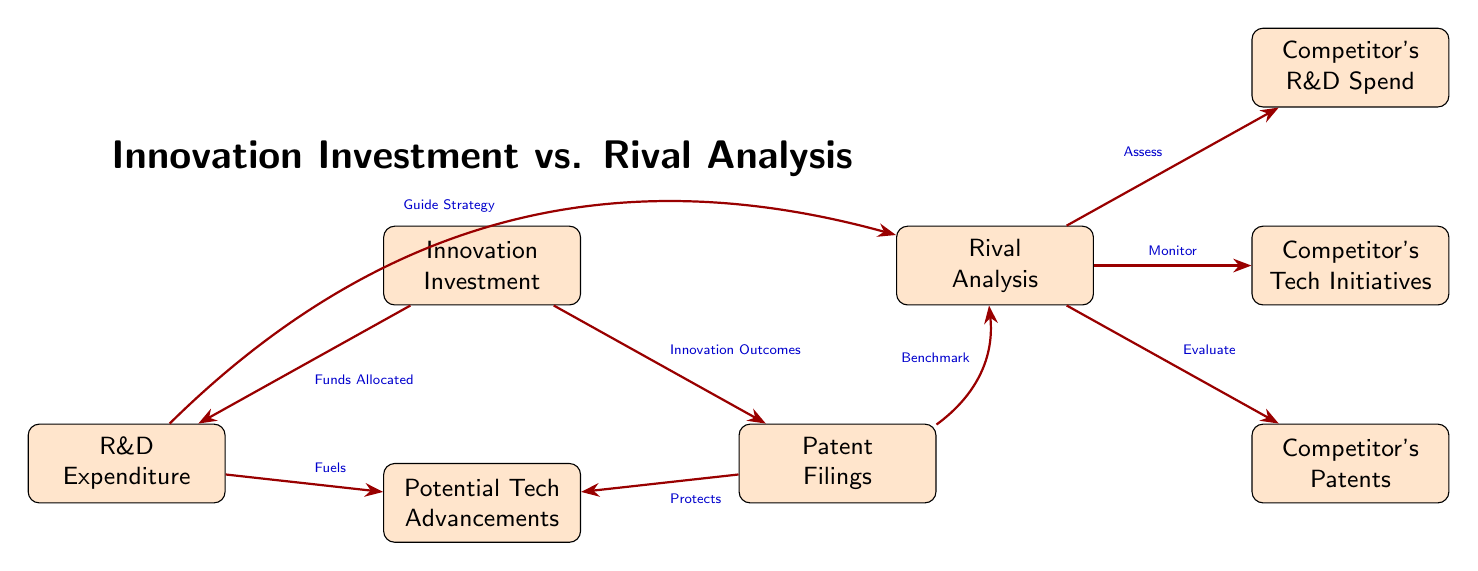What is the main focus of the diagram? The diagram illustrates the relationship between Innovation Investment and Rival Analysis, showing how R&D expenditure and patent filings contribute to potential tech advancements and how these interact with competitors.
Answer: Innovation Investment vs. Rival Analysis How many nodes are in the diagram? There are six nodes in the diagram: Innovation Investment, R&D Expenditure, Patent Filings, Potential Tech Advancements, Rival Analysis, and Competitor's Tech Initiatives.
Answer: Six nodes What are the two outcomes of Innovation Investment? The two outcomes directly linked to Innovation Investment are R&D Expenditure and Patent Filings.
Answer: R&D Expenditure and Patent Filings How does R&D Expenditure influence Potential Tech Advancements? R&D Expenditure fuels Potential Tech Advancements, indicating that increased spending on R&D enhances technological progress.
Answer: Fuels What does the arrow from Patents to Potential Tech Advancements signify? The arrow indicates that patents protect the technology advancements, suggesting that having patents secures the results of innovation efforts.
Answer: Protects How does Rival Analysis interact with R&D expenditures? The diagram indicates that R&D expenditures guide strategy for Rival Analysis, suggesting that insights from R&D inform competitive strategies.
Answer: Guide Strategy What role do Patent Filings play in Rival Analysis? Patent Filings serve as a benchmark for Rival Analysis, allowing comparison of a firm's innovations to its competitors' innovations.
Answer: Benchmark Which node evaluates competitors' patents? The node labeled "Evaluate" points to Competitor's Patents, indicating that this node assesses patent filings of rival firms.
Answer: Competitor's Patents What does the diagram imply about the relationship between innovation and competition? The diagram suggests that innovation (through investment in R&D and patents) is closely linked to competitive dynamics, influencing both a firm's strategy and its assessment of competitors' moves.
Answer: Innovation drives competition 